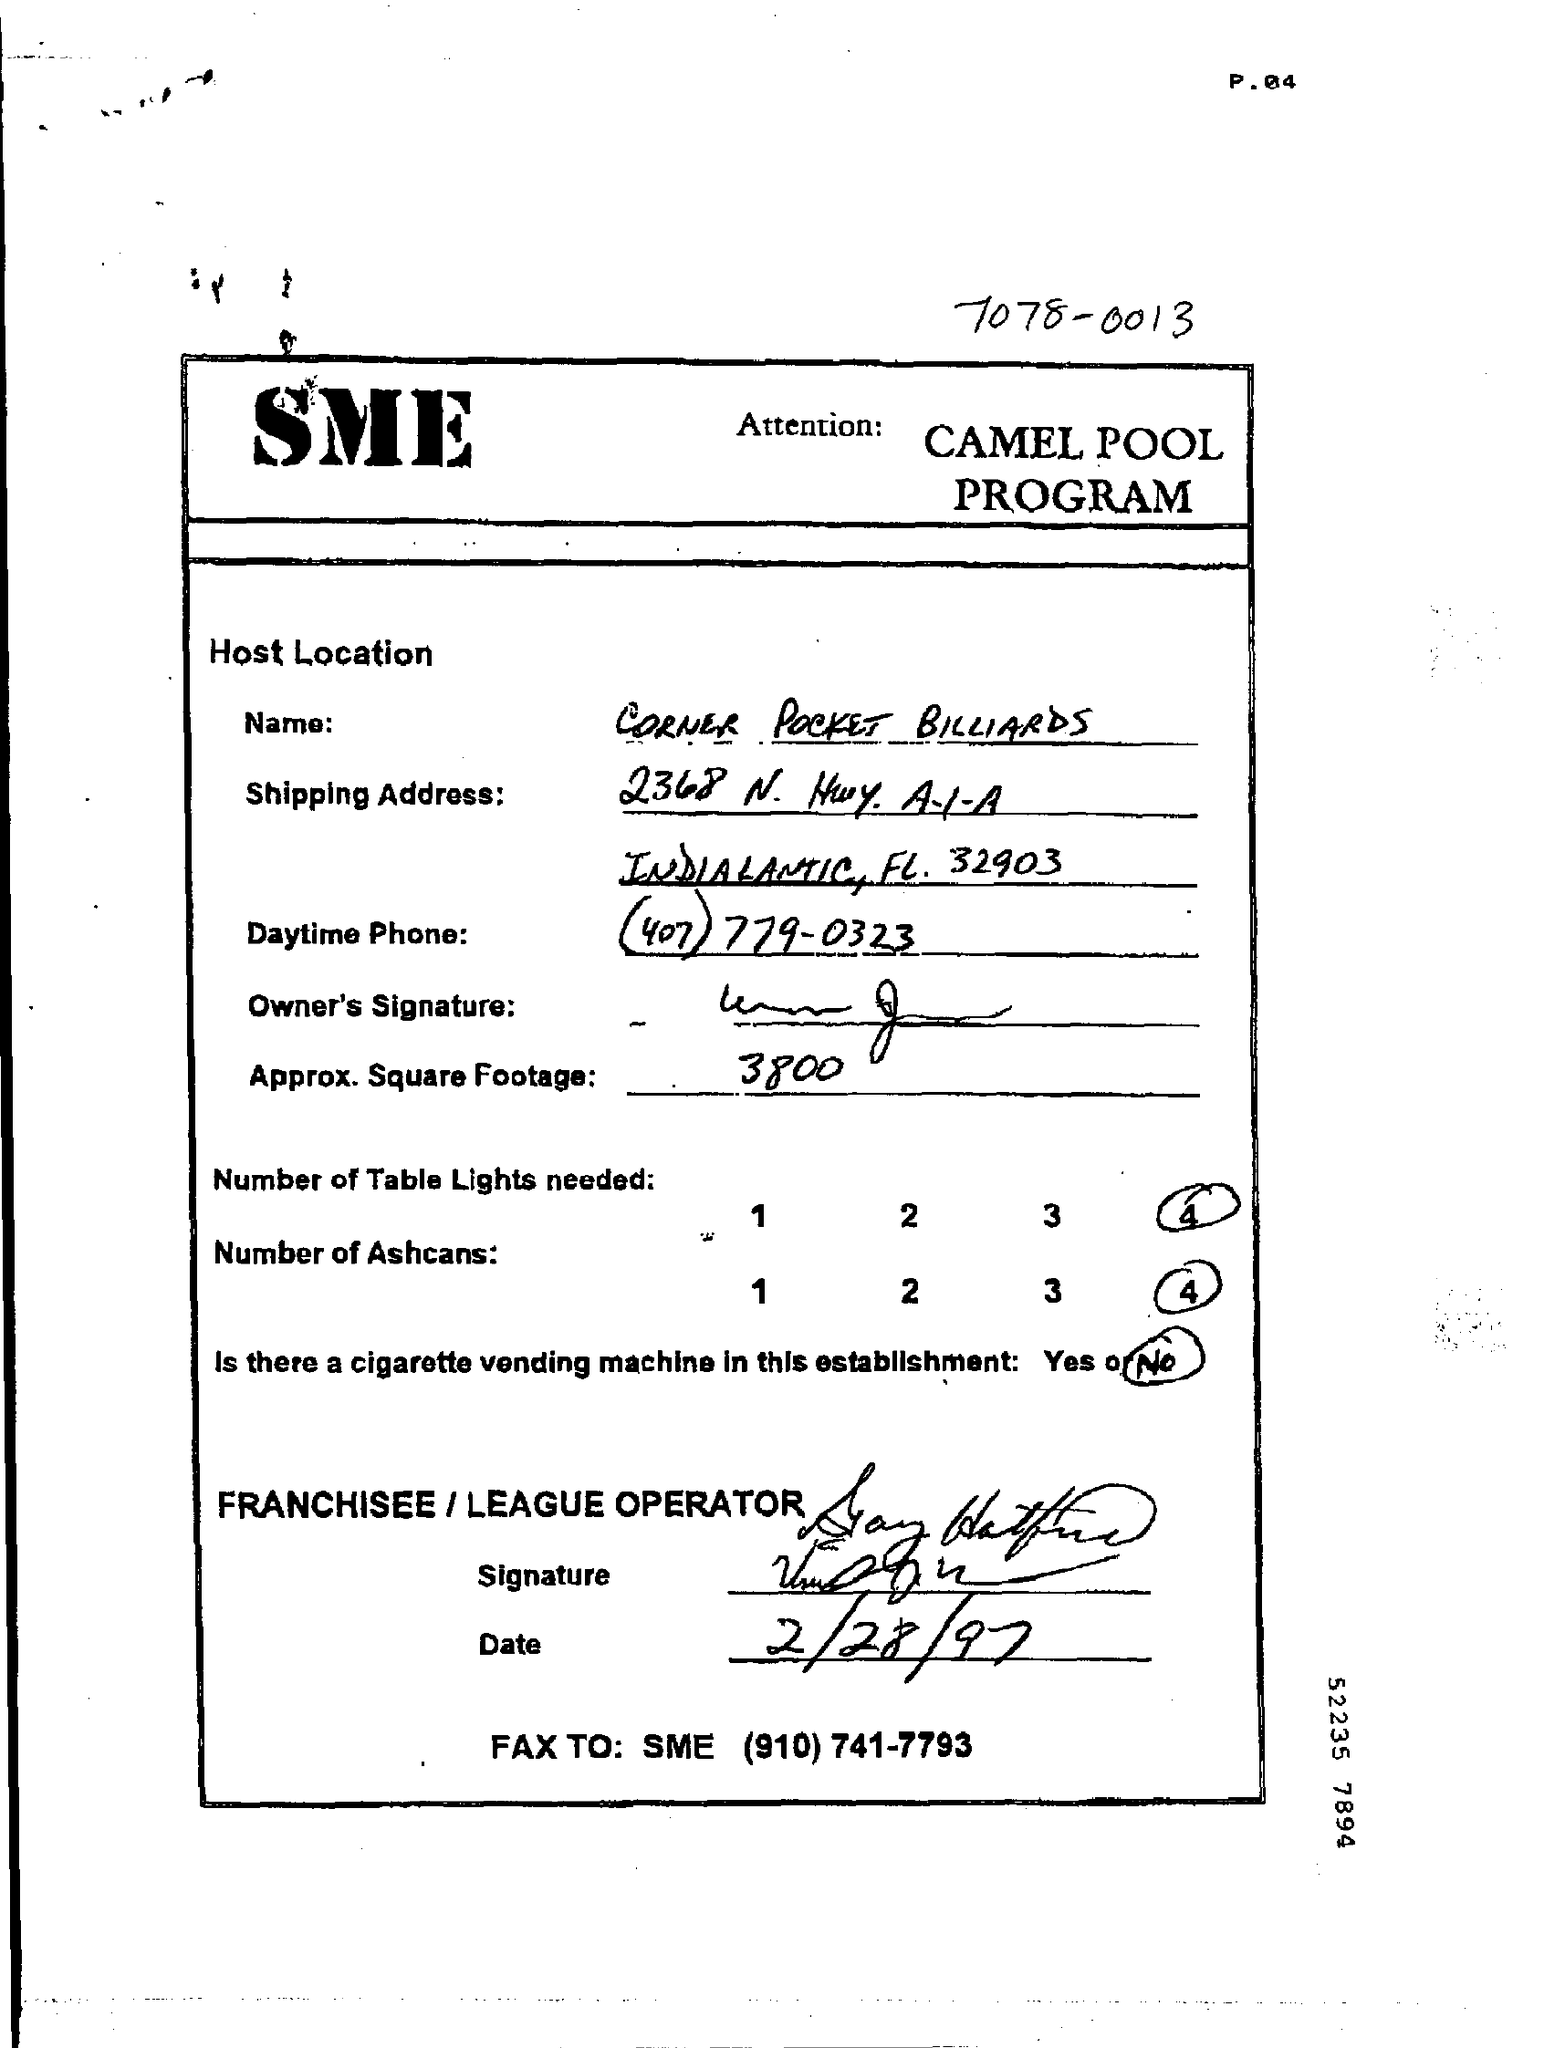List a handful of essential elements in this visual. The name given to Corner Pocket Billiards is [Corner Pocket Billiards]. The document is dated 2/28/97. The approximate square footage is 3,800 square feet. There is no cigarette vending machine in this establishment. Four table lamps will be necessary. 